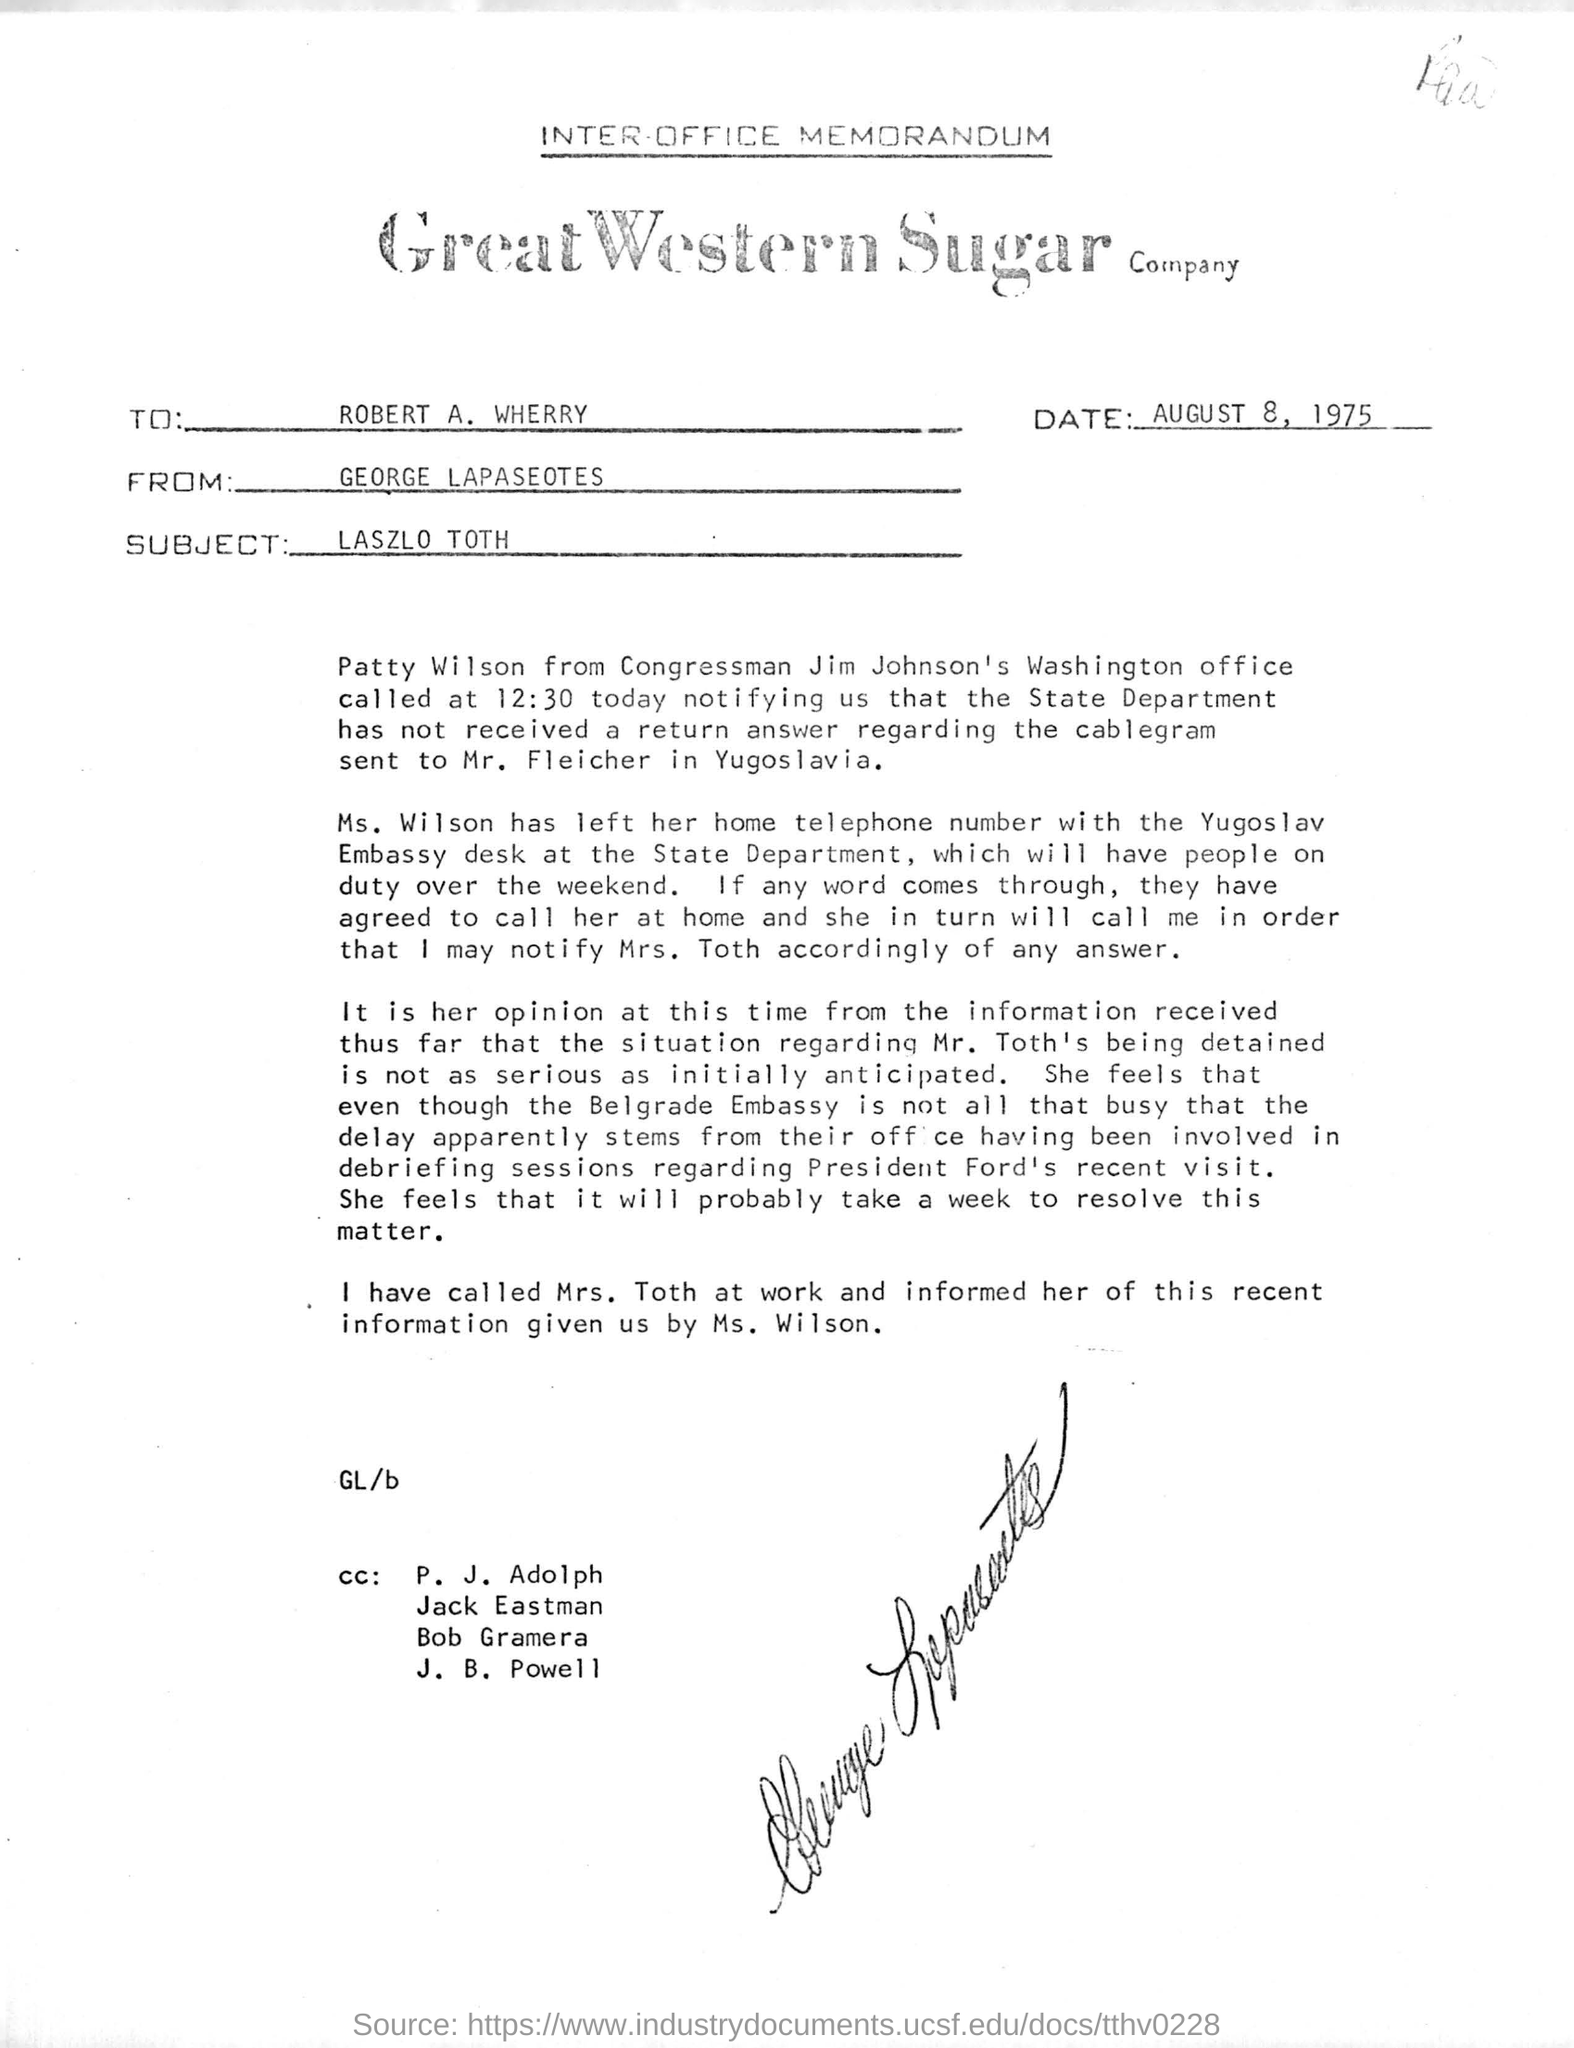Specify some key components in this picture. The memorandum is from George Lapaseotes. August 8, 1975, is the date of the memorandum. The subject of the memorandum is Laszlo Toth. 